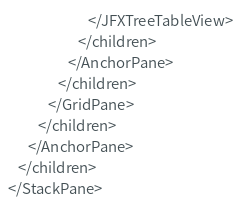Convert code to text. <code><loc_0><loc_0><loc_500><loc_500><_XML_>                        </JFXTreeTableView>
                     </children>
                  </AnchorPane>
               </children>
            </GridPane>
         </children>
      </AnchorPane>
   </children>
</StackPane>
</code> 